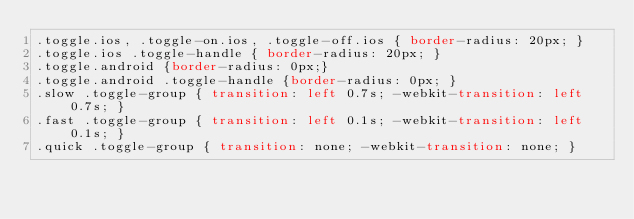<code> <loc_0><loc_0><loc_500><loc_500><_CSS_>.toggle.ios, .toggle-on.ios, .toggle-off.ios { border-radius: 20px; }
.toggle.ios .toggle-handle { border-radius: 20px; }
.toggle.android {border-radius: 0px;}
.toggle.android .toggle-handle {border-radius: 0px; }
.slow .toggle-group { transition: left 0.7s; -webkit-transition: left 0.7s; }
.fast .toggle-group { transition: left 0.1s; -webkit-transition: left 0.1s; }
.quick .toggle-group { transition: none; -webkit-transition: none; }</code> 